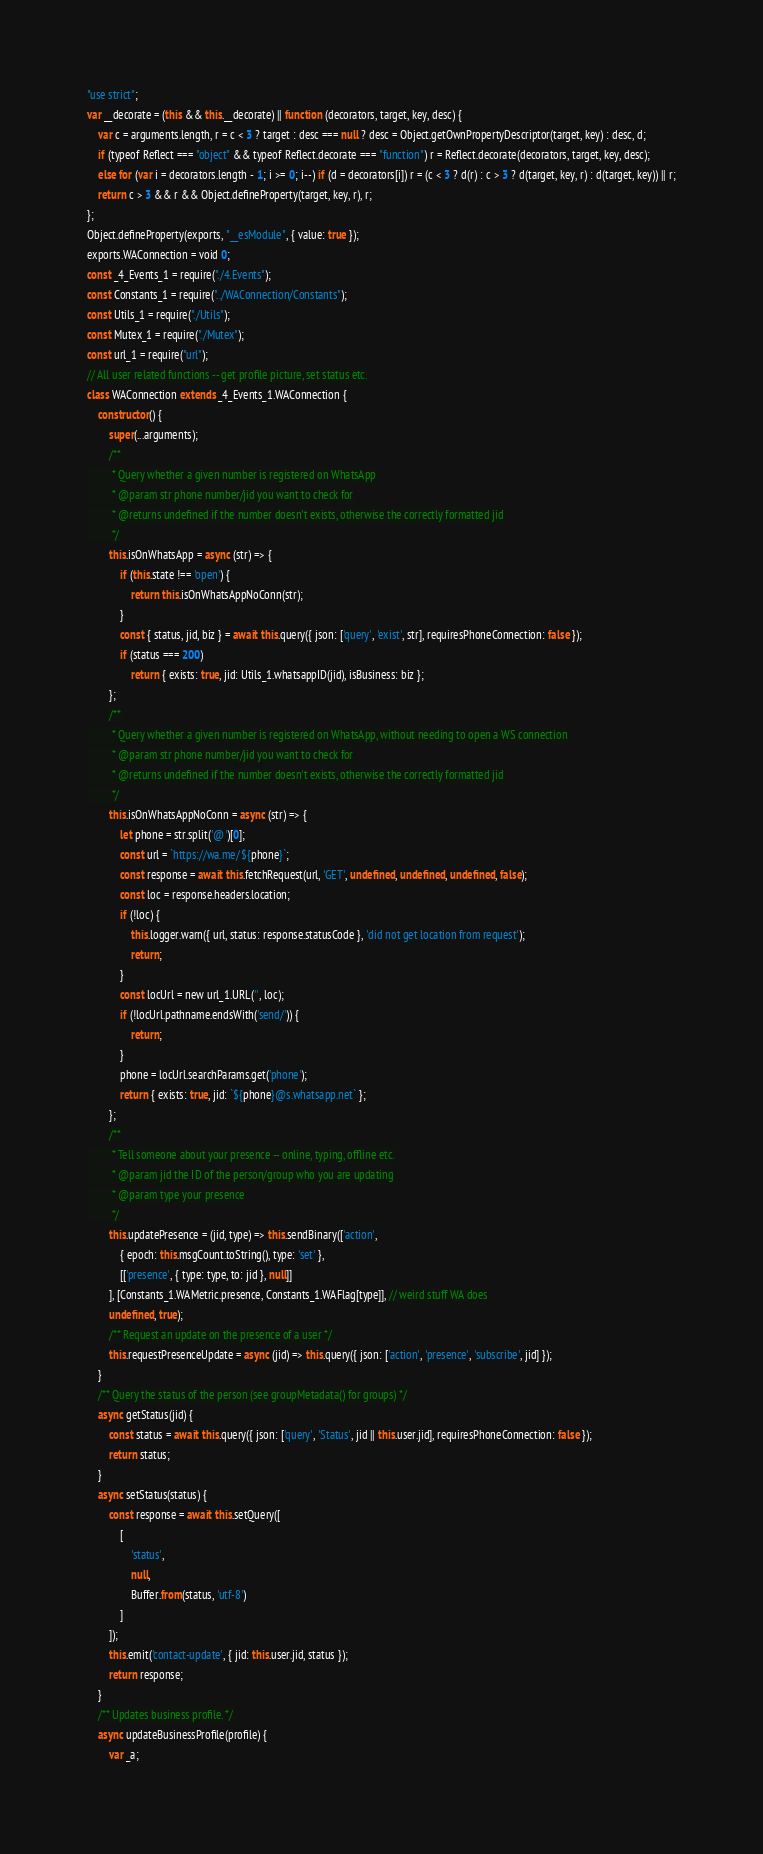<code> <loc_0><loc_0><loc_500><loc_500><_JavaScript_>"use strict";
var __decorate = (this && this.__decorate) || function (decorators, target, key, desc) {
    var c = arguments.length, r = c < 3 ? target : desc === null ? desc = Object.getOwnPropertyDescriptor(target, key) : desc, d;
    if (typeof Reflect === "object" && typeof Reflect.decorate === "function") r = Reflect.decorate(decorators, target, key, desc);
    else for (var i = decorators.length - 1; i >= 0; i--) if (d = decorators[i]) r = (c < 3 ? d(r) : c > 3 ? d(target, key, r) : d(target, key)) || r;
    return c > 3 && r && Object.defineProperty(target, key, r), r;
};
Object.defineProperty(exports, "__esModule", { value: true });
exports.WAConnection = void 0;
const _4_Events_1 = require("./4.Events");
const Constants_1 = require("../WAConnection/Constants");
const Utils_1 = require("./Utils");
const Mutex_1 = require("./Mutex");
const url_1 = require("url");
// All user related functions -- get profile picture, set status etc.
class WAConnection extends _4_Events_1.WAConnection {
    constructor() {
        super(...arguments);
        /**
         * Query whether a given number is registered on WhatsApp
         * @param str phone number/jid you want to check for
         * @returns undefined if the number doesn't exists, otherwise the correctly formatted jid
         */
        this.isOnWhatsApp = async (str) => {
            if (this.state !== 'open') {
                return this.isOnWhatsAppNoConn(str);
            }
            const { status, jid, biz } = await this.query({ json: ['query', 'exist', str], requiresPhoneConnection: false });
            if (status === 200)
                return { exists: true, jid: Utils_1.whatsappID(jid), isBusiness: biz };
        };
        /**
         * Query whether a given number is registered on WhatsApp, without needing to open a WS connection
         * @param str phone number/jid you want to check for
         * @returns undefined if the number doesn't exists, otherwise the correctly formatted jid
         */
        this.isOnWhatsAppNoConn = async (str) => {
            let phone = str.split('@')[0];
            const url = `https://wa.me/${phone}`;
            const response = await this.fetchRequest(url, 'GET', undefined, undefined, undefined, false);
            const loc = response.headers.location;
            if (!loc) {
                this.logger.warn({ url, status: response.statusCode }, 'did not get location from request');
                return;
            }
            const locUrl = new url_1.URL('', loc);
            if (!locUrl.pathname.endsWith('send/')) {
                return;
            }
            phone = locUrl.searchParams.get('phone');
            return { exists: true, jid: `${phone}@s.whatsapp.net` };
        };
        /**
         * Tell someone about your presence -- online, typing, offline etc.
         * @param jid the ID of the person/group who you are updating
         * @param type your presence
         */
        this.updatePresence = (jid, type) => this.sendBinary(['action',
            { epoch: this.msgCount.toString(), type: 'set' },
            [['presence', { type: type, to: jid }, null]]
        ], [Constants_1.WAMetric.presence, Constants_1.WAFlag[type]], // weird stuff WA does
        undefined, true);
        /** Request an update on the presence of a user */
        this.requestPresenceUpdate = async (jid) => this.query({ json: ['action', 'presence', 'subscribe', jid] });
    }
    /** Query the status of the person (see groupMetadata() for groups) */
    async getStatus(jid) {
        const status = await this.query({ json: ['query', 'Status', jid || this.user.jid], requiresPhoneConnection: false });
        return status;
    }
    async setStatus(status) {
        const response = await this.setQuery([
            [
                'status',
                null,
                Buffer.from(status, 'utf-8')
            ]
        ]);
        this.emit('contact-update', { jid: this.user.jid, status });
        return response;
    }
    /** Updates business profile. */
    async updateBusinessProfile(profile) {
        var _a;</code> 